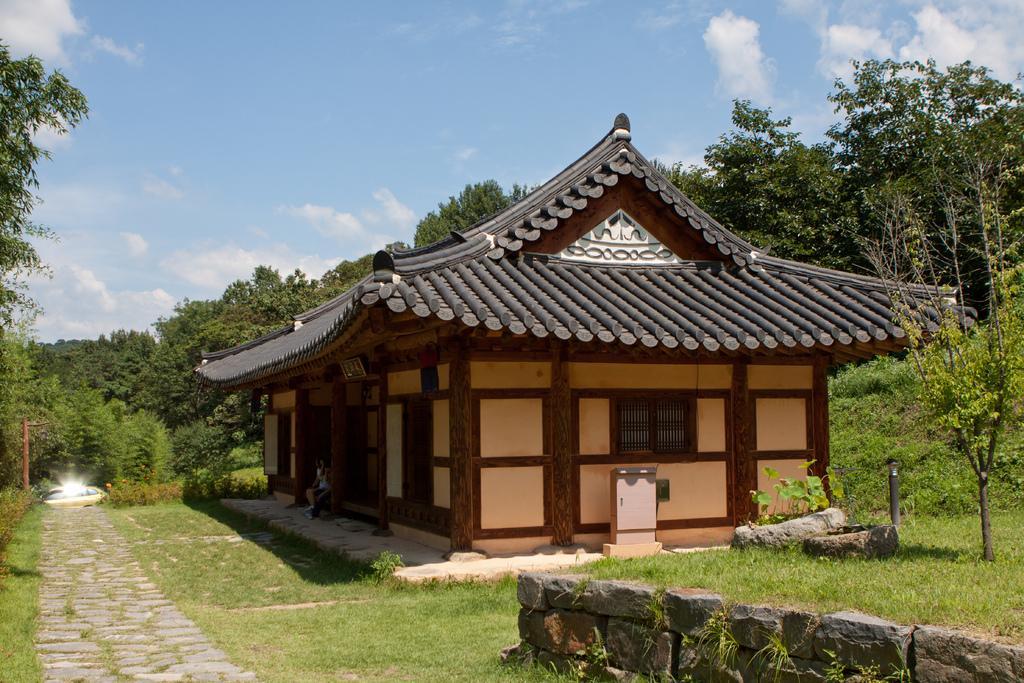Could you give a brief overview of what you see in this image? In this picture we can see grass, stonewall on the ground, here we can see a house, trees and in the background we can see sky with clouds. 